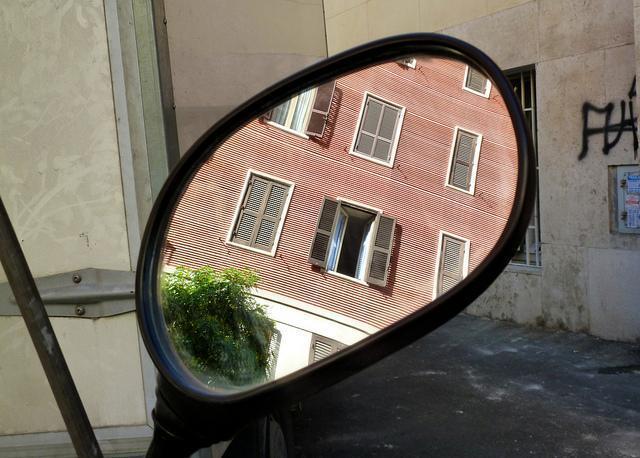How many windows are open?
Give a very brief answer. 2. 